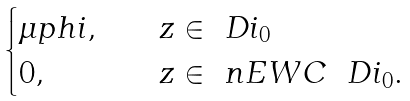Convert formula to latex. <formula><loc_0><loc_0><loc_500><loc_500>\begin{cases} \mu p h i , & \quad z \in \ D i _ { 0 } \\ 0 , & \quad z \in { \ n E W C } \ \ D i _ { 0 } . \end{cases}</formula> 